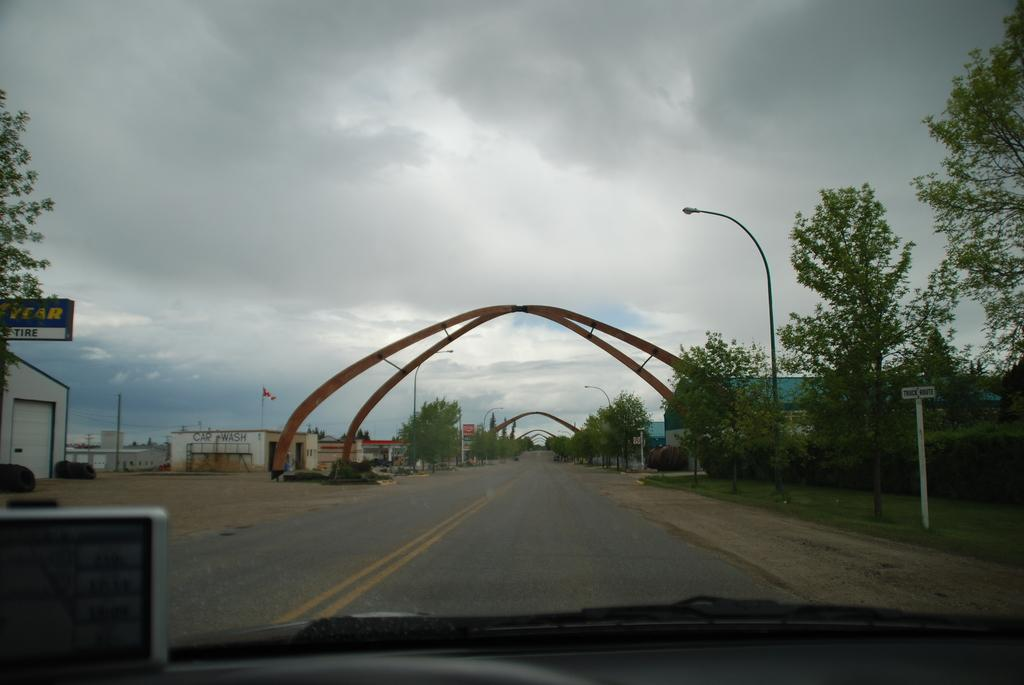What is the main feature of the image? There is a road in the image. What can be seen on both sides of the road? Trees, poles, and buildings are present on both sides of the road. What is the condition of the sky in the image? The sky is covered with clouds. How many giants are holding the buildings in the image? There are no giants present in the image; the buildings are standing on their own. What type of balls can be seen bouncing on the road in the image? There are no balls present in the image; the road is clear of any objects. 